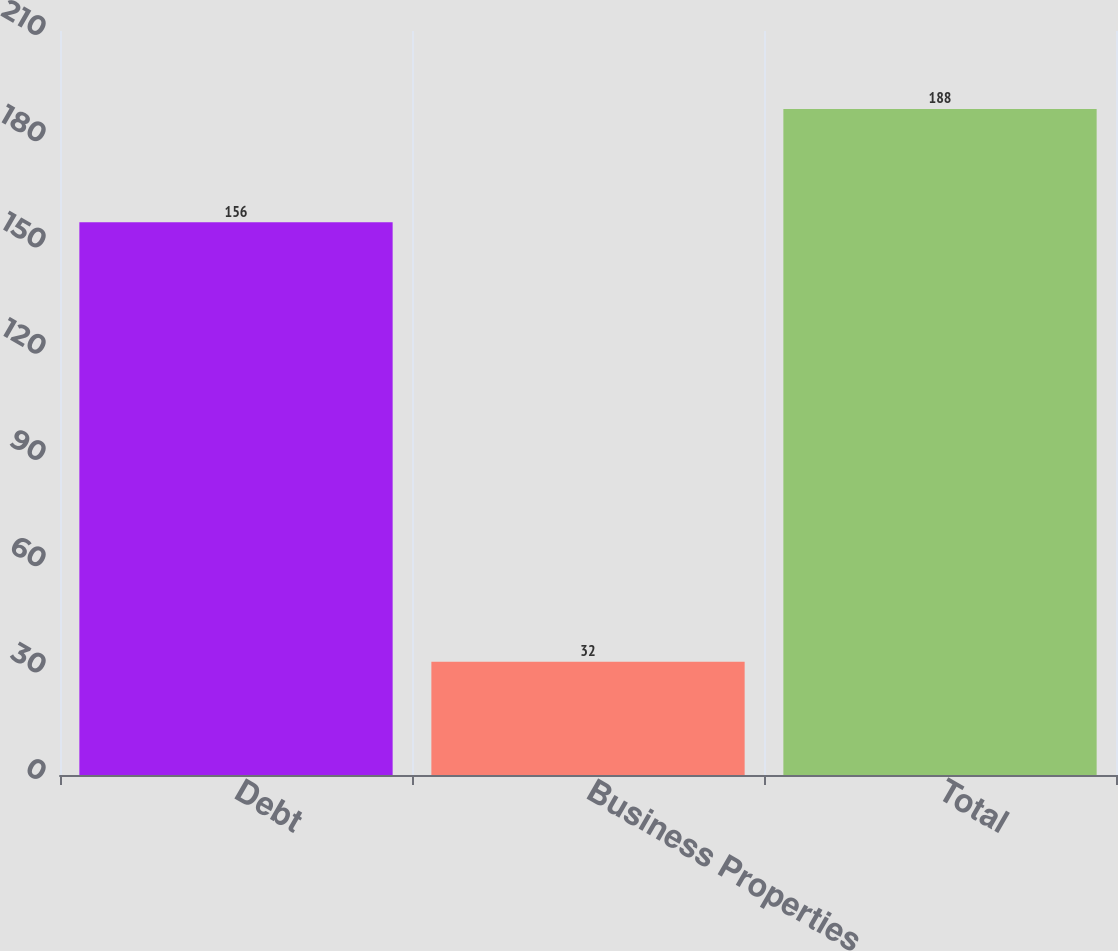Convert chart to OTSL. <chart><loc_0><loc_0><loc_500><loc_500><bar_chart><fcel>Debt<fcel>Business Properties<fcel>Total<nl><fcel>156<fcel>32<fcel>188<nl></chart> 